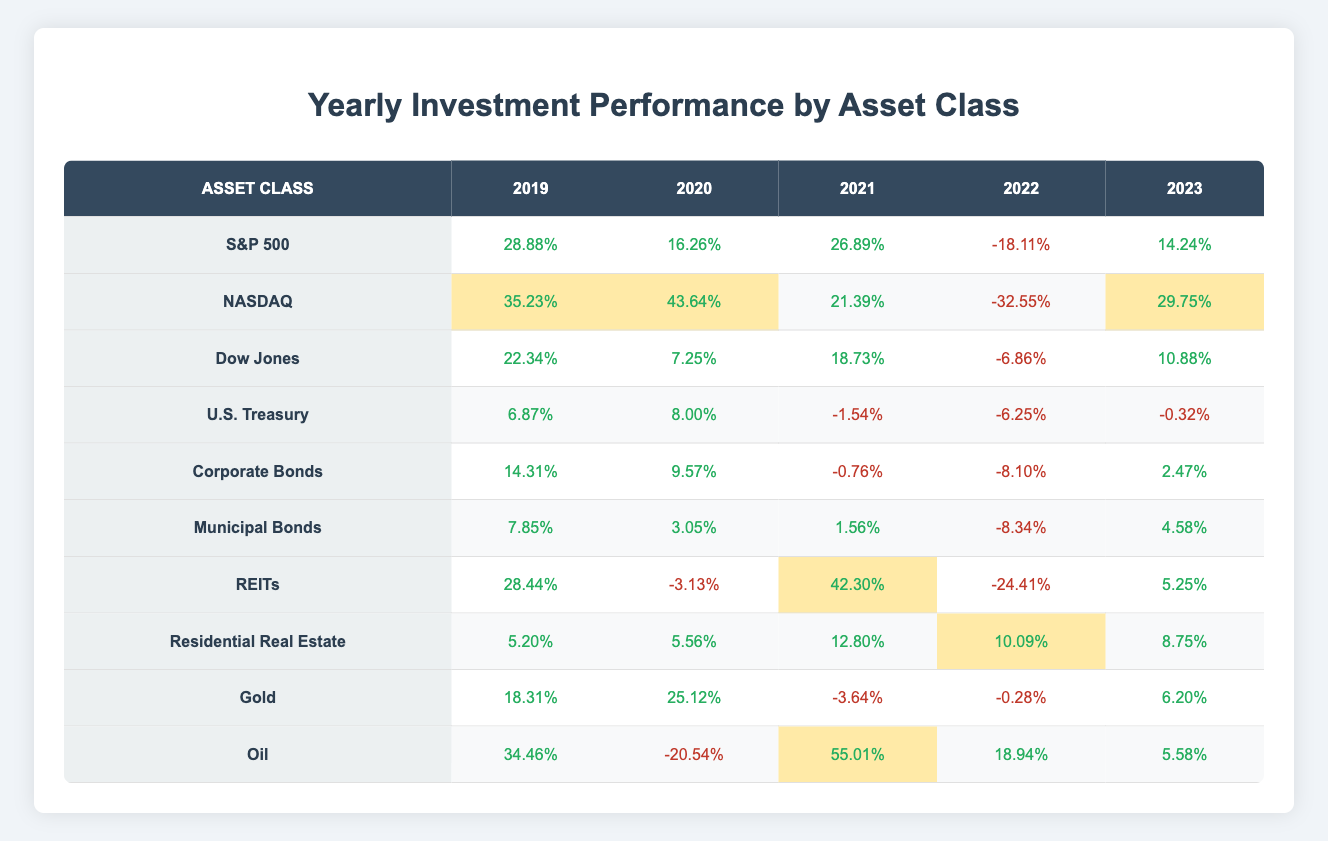What was the performance of NASDAQ in 2020? The table indicates that NASDAQ had a performance of 43.64% in 2020.
Answer: 43.64% Which asset class had the highest performance in 2021? By inspecting the table, REITs had the highest performance in 2021 with a return of 42.30%.
Answer: REITs How did the performance of Corporate Bonds change from 2019 to 2023? The performance of Corporate Bonds was 14.31% in 2019, decreased to 9.57% in 2020, then to -0.76% in 2021, further down to -8.10% in 2022, and finally improved to 2.47% in 2023. Hence, it experienced a downward trend followed by a slight recovery in 2023.
Answer: Downward trend then slight recovery What is the average performance of Residential Real Estate over the five years? To find the average, we sum the performances: (5.20 + 5.56 + 12.80 + 10.09 + 8.75) = 42.4, then divide by 5: 42.4/5 = 8.48%.
Answer: 8.48% Did the S&P 500 have a positive performance in 2022? The table shows that S&P 500 had a performance of -18.11% in 2022, which is negative.
Answer: No What was the change in performance for Gold from 2020 to 2022? In 2020, Gold performed at 25.12%, which then dropped to -0.28% in 2022. The change is calculated as (25.12 - (-0.28)) = 25.4%. Thus, there was a decrease of 25.4%.
Answer: Decrease of 25.4% Which asset class consistently performed positively from 2019 to 2023? By examining each year for all asset classes, Municipal Bonds showed positive returns in 2019, 2020, and 2021, while only turning negative in 2022 before returning positive in 2023. However, no class was consistently positive for all five years.
Answer: None What was the largest decline in performance for any asset class within a single year? The largest decline occurred in NASDAQ in 2022 with a performance of -32.55%, which is the most negative value from the table.
Answer: -32.55% in 2022 How did the performance of Oil compare to Gold in 2021? In 2021, Oil had a performance of 55.01%, while Gold had a performance of -3.64%. Therefore, Oil significantly outperformed Gold in that year.
Answer: Oil outperformed Gold 